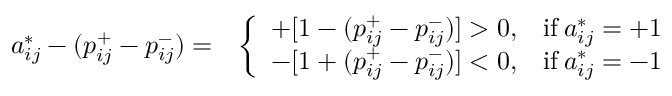<formula> <loc_0><loc_0><loc_500><loc_500>\begin{array} { r l } { a _ { i j } ^ { * } - ( p _ { i j } ^ { + } - p _ { i j } ^ { - } ) = } & { \left \{ \begin{array} { l l } { + [ 1 - ( p _ { i j } ^ { + } - p _ { i j } ^ { - } ) ] > 0 , } & { i f \, a _ { i j } ^ { * } = + 1 } \\ { - [ 1 + ( p _ { i j } ^ { + } - p _ { i j } ^ { - } ) ] < 0 , } & { i f \, a _ { i j } ^ { * } = - 1 } \end{array} } \end{array}</formula> 